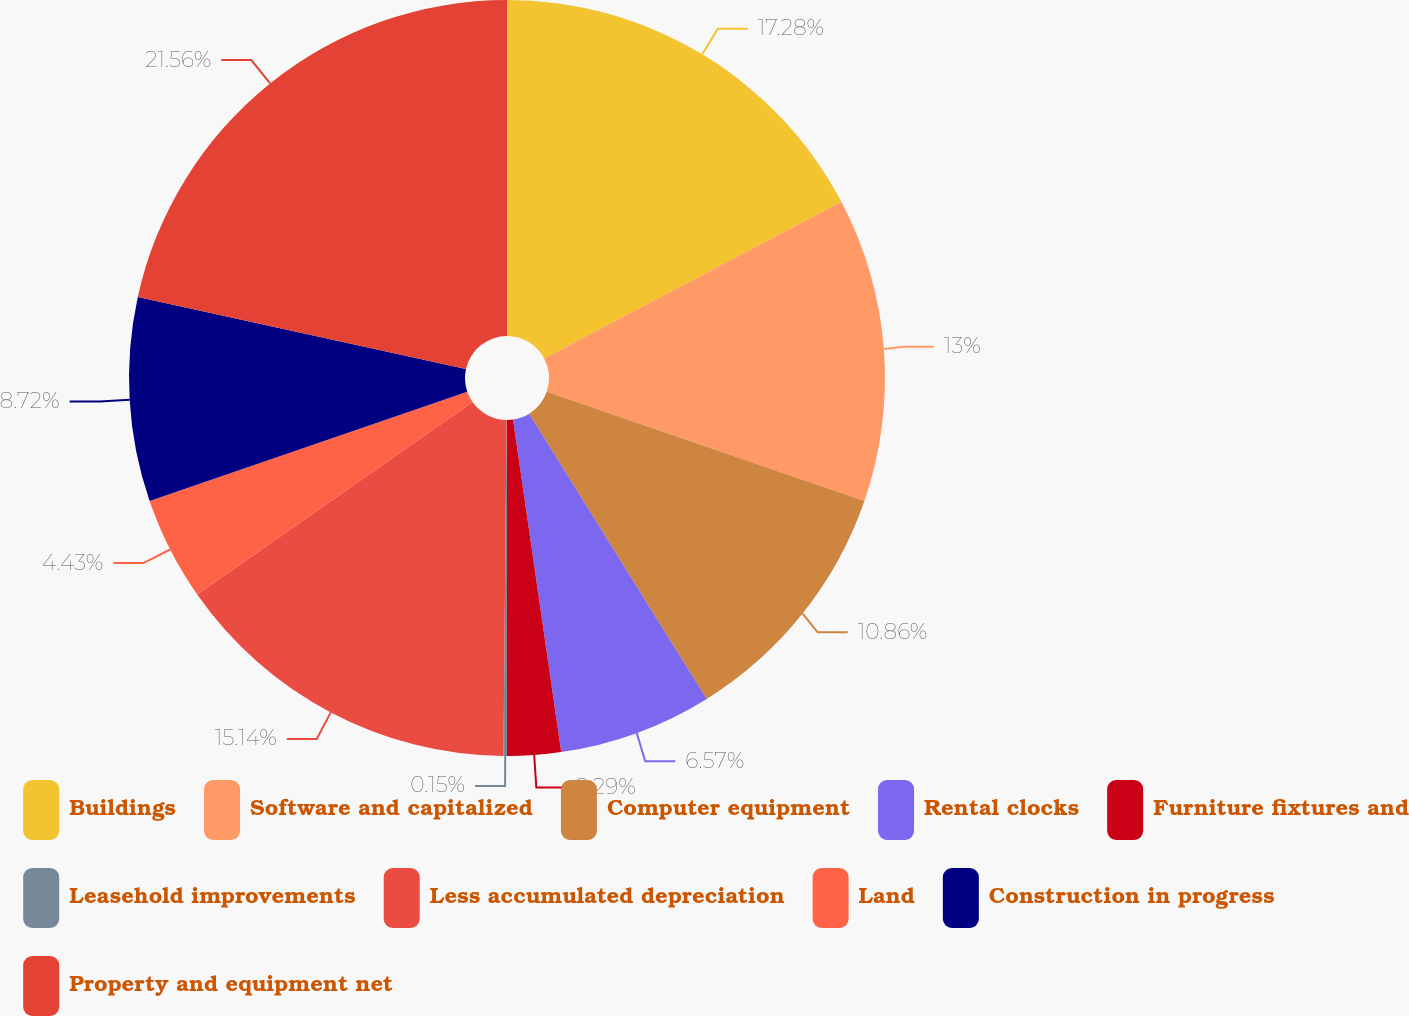Convert chart. <chart><loc_0><loc_0><loc_500><loc_500><pie_chart><fcel>Buildings<fcel>Software and capitalized<fcel>Computer equipment<fcel>Rental clocks<fcel>Furniture fixtures and<fcel>Leasehold improvements<fcel>Less accumulated depreciation<fcel>Land<fcel>Construction in progress<fcel>Property and equipment net<nl><fcel>17.28%<fcel>13.0%<fcel>10.86%<fcel>6.57%<fcel>2.29%<fcel>0.15%<fcel>15.14%<fcel>4.43%<fcel>8.72%<fcel>21.56%<nl></chart> 